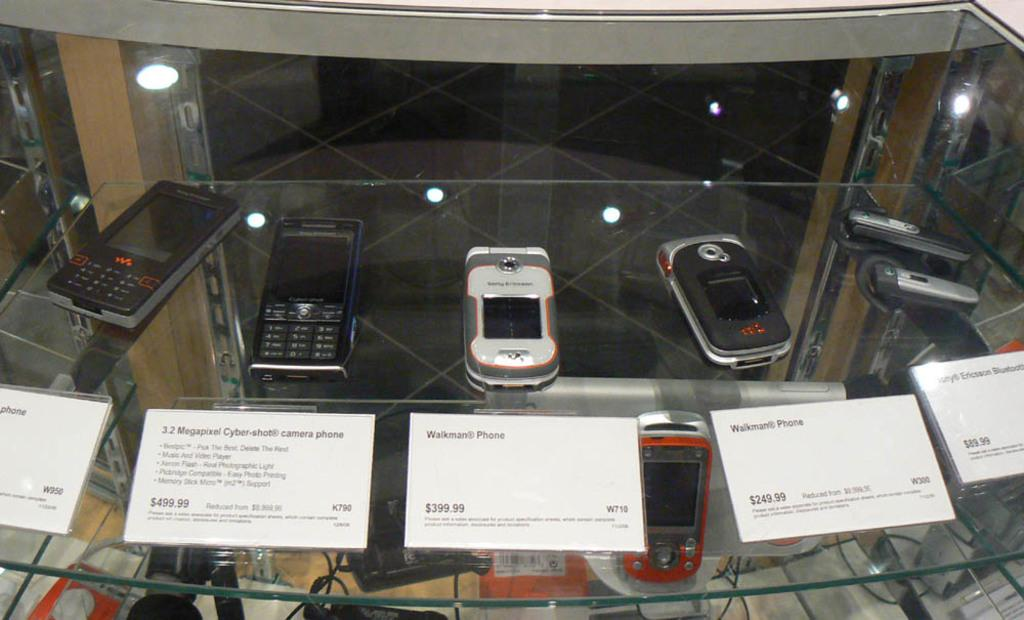<image>
Provide a brief description of the given image. Different phones with prices are displayed including a Walkman phone 